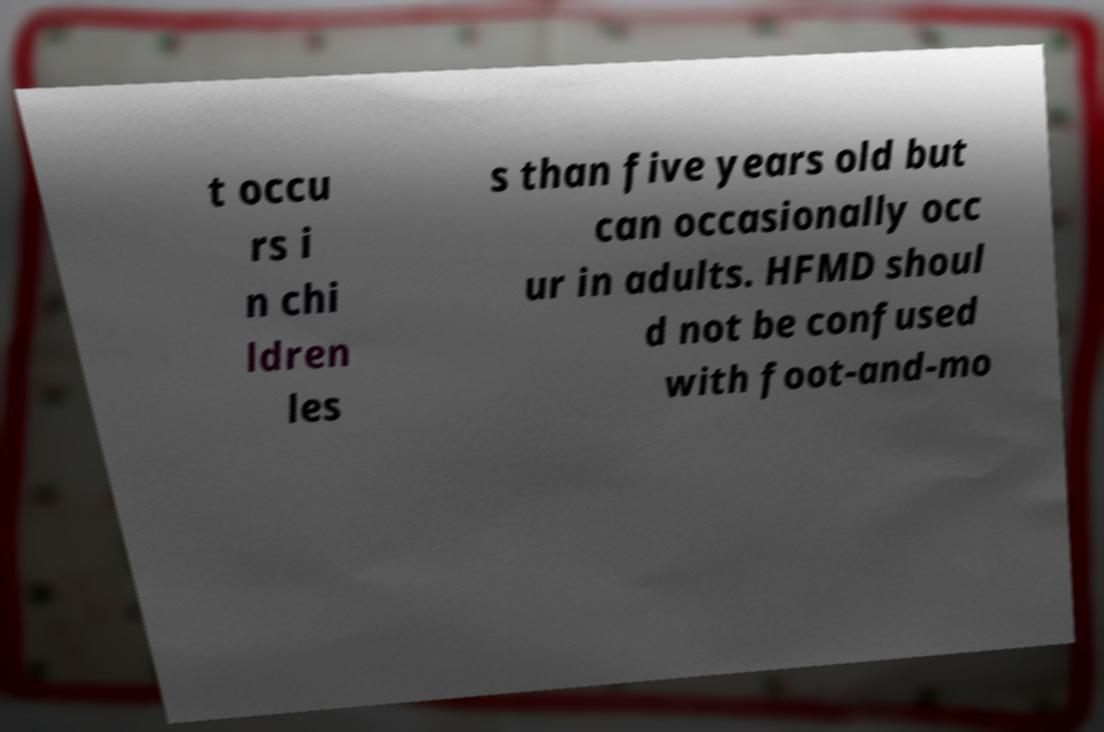Please identify and transcribe the text found in this image. t occu rs i n chi ldren les s than five years old but can occasionally occ ur in adults. HFMD shoul d not be confused with foot-and-mo 